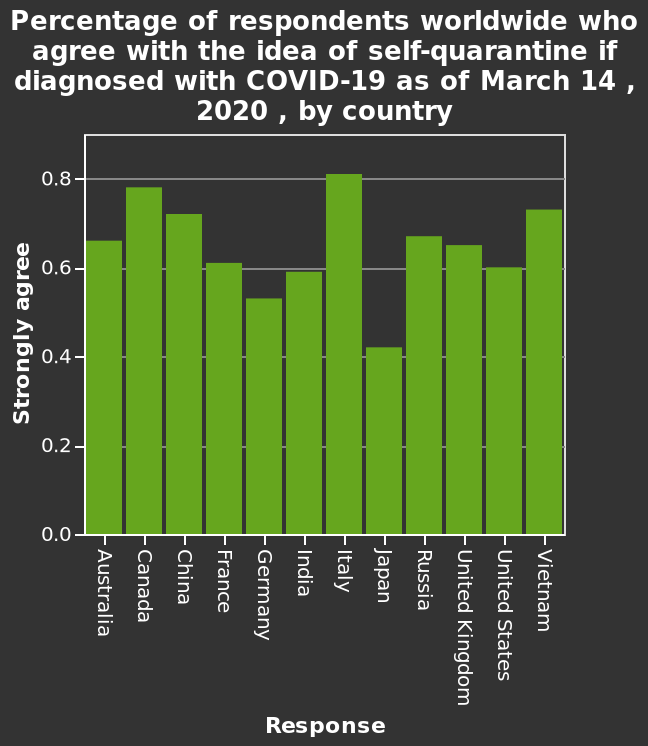<image>
What is the date associated with the data presented in the bar diagram? The data in the bar diagram is from March 14, 2020. Offer a thorough analysis of the image. It is evident that Italy agree the most with the idea of self quarantine to isolate from Covid, with their percentage being over 80%. Japan falls the lowest with just over 40% of people agreeing with the quarantine. It appears that all European counties reach over 50% or higher agreement that people should self isolate when contracting covid-19. 